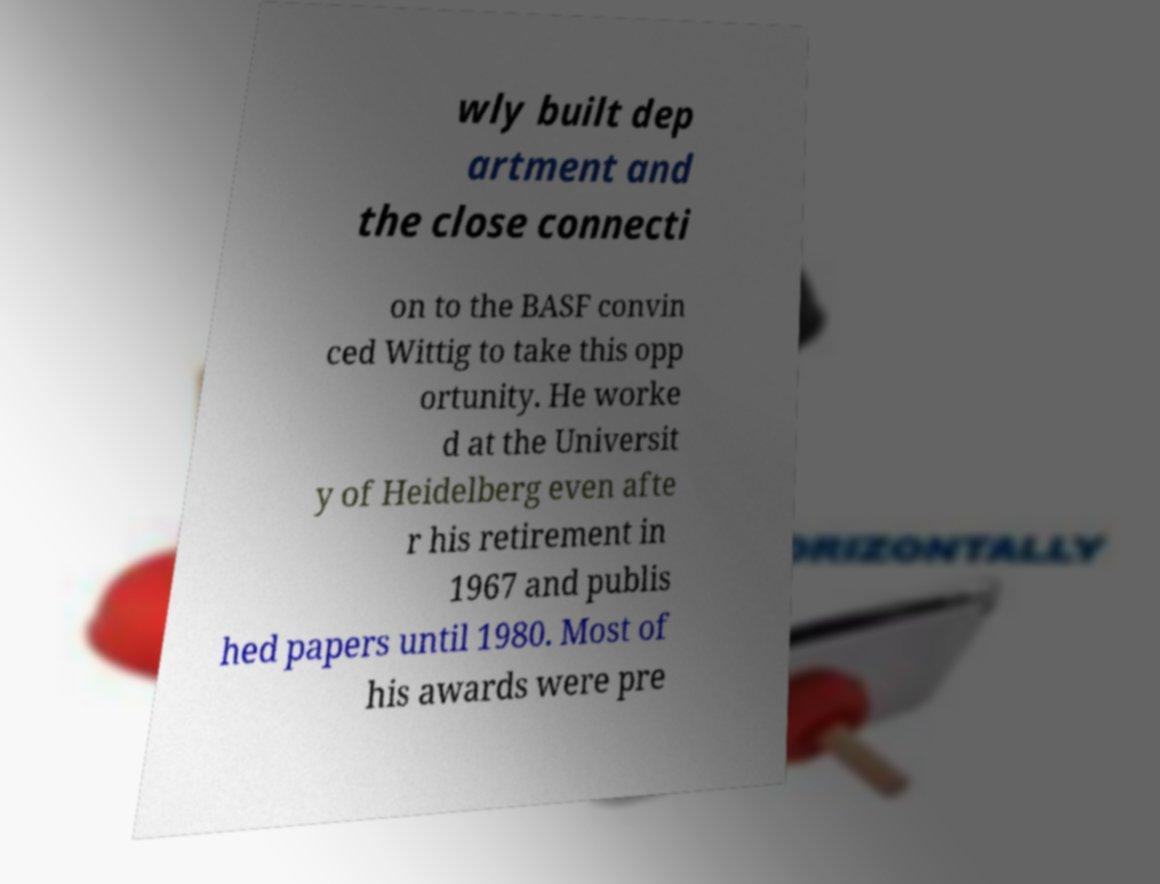What messages or text are displayed in this image? I need them in a readable, typed format. wly built dep artment and the close connecti on to the BASF convin ced Wittig to take this opp ortunity. He worke d at the Universit y of Heidelberg even afte r his retirement in 1967 and publis hed papers until 1980. Most of his awards were pre 